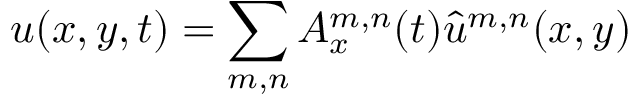<formula> <loc_0><loc_0><loc_500><loc_500>u ( x , y , t ) = \sum _ { m , n } A _ { x } ^ { m , n } ( t ) \hat { u } ^ { m , n } ( x , y )</formula> 